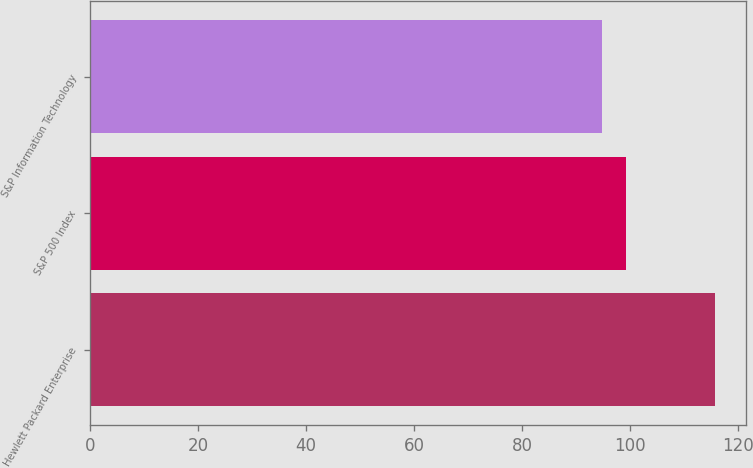Convert chart to OTSL. <chart><loc_0><loc_0><loc_500><loc_500><bar_chart><fcel>Hewlett Packard Enterprise<fcel>S&P 500 Index<fcel>S&P Information Technology<nl><fcel>115.78<fcel>99.25<fcel>94.74<nl></chart> 